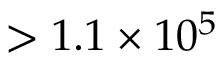Convert formula to latex. <formula><loc_0><loc_0><loc_500><loc_500>> 1 . 1 \times 1 0 ^ { 5 }</formula> 